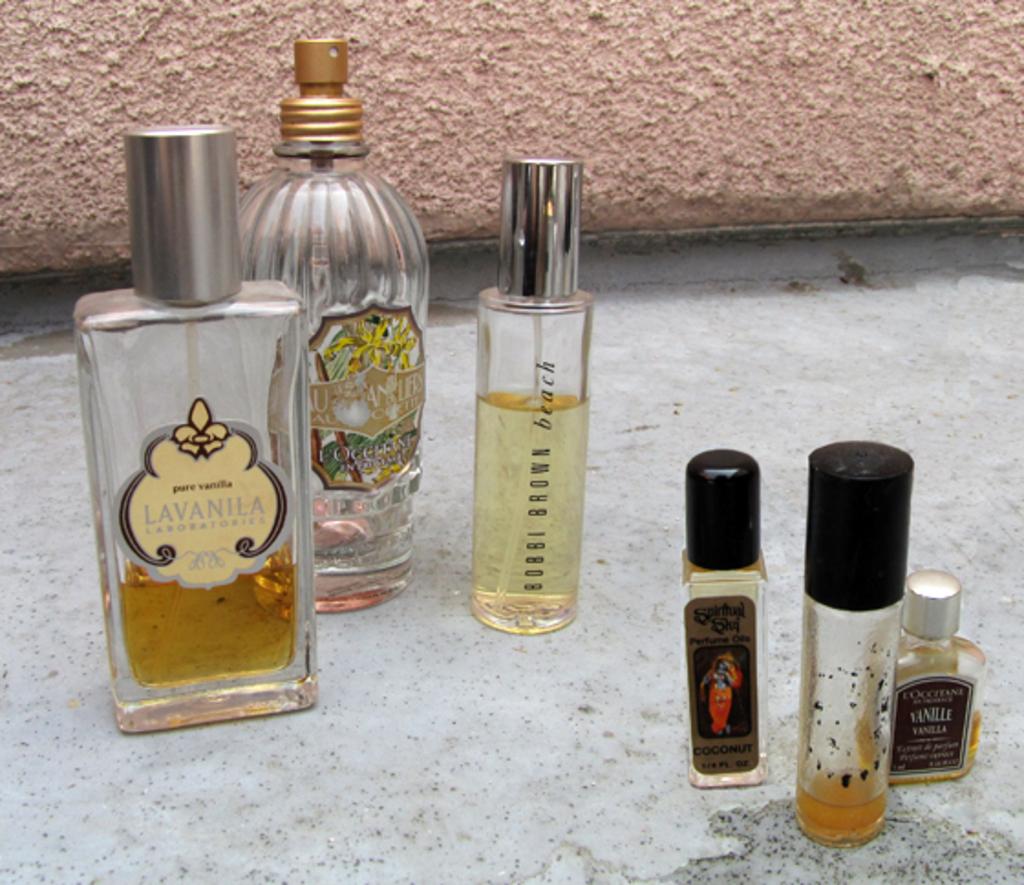Name the fragrance to the left?
Your answer should be compact. Lavanila. 